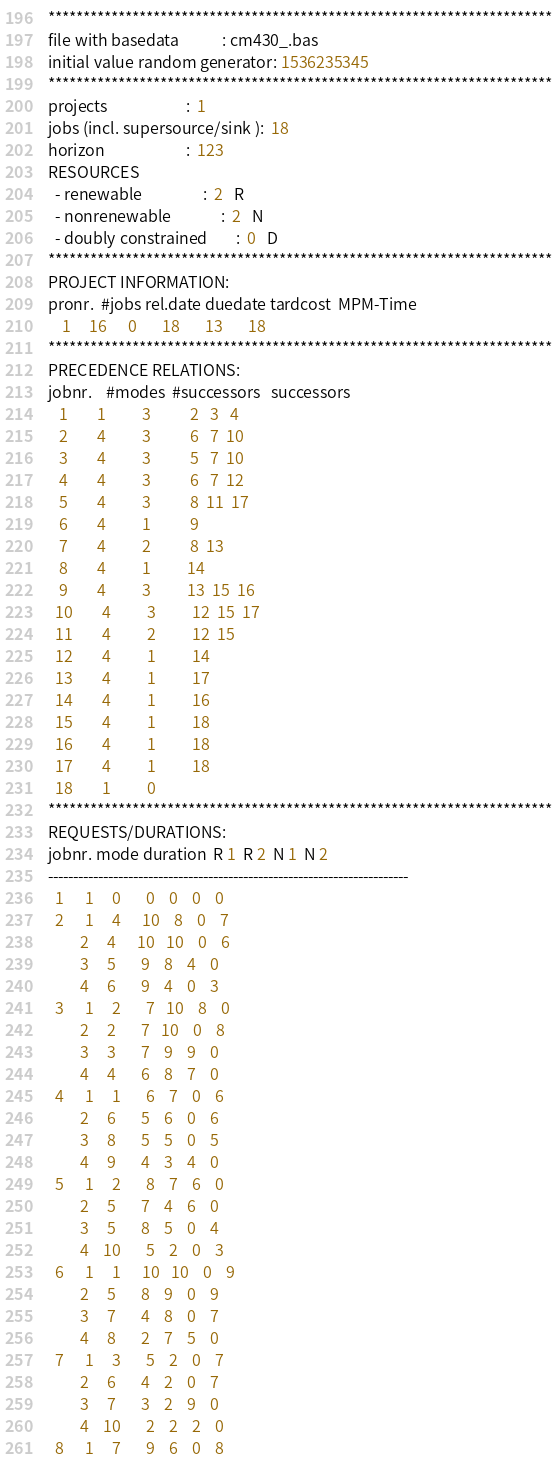Convert code to text. <code><loc_0><loc_0><loc_500><loc_500><_ObjectiveC_>************************************************************************
file with basedata            : cm430_.bas
initial value random generator: 1536235345
************************************************************************
projects                      :  1
jobs (incl. supersource/sink ):  18
horizon                       :  123
RESOURCES
  - renewable                 :  2   R
  - nonrenewable              :  2   N
  - doubly constrained        :  0   D
************************************************************************
PROJECT INFORMATION:
pronr.  #jobs rel.date duedate tardcost  MPM-Time
    1     16      0       18       13       18
************************************************************************
PRECEDENCE RELATIONS:
jobnr.    #modes  #successors   successors
   1        1          3           2   3   4
   2        4          3           6   7  10
   3        4          3           5   7  10
   4        4          3           6   7  12
   5        4          3           8  11  17
   6        4          1           9
   7        4          2           8  13
   8        4          1          14
   9        4          3          13  15  16
  10        4          3          12  15  17
  11        4          2          12  15
  12        4          1          14
  13        4          1          17
  14        4          1          16
  15        4          1          18
  16        4          1          18
  17        4          1          18
  18        1          0        
************************************************************************
REQUESTS/DURATIONS:
jobnr. mode duration  R 1  R 2  N 1  N 2
------------------------------------------------------------------------
  1      1     0       0    0    0    0
  2      1     4      10    8    0    7
         2     4      10   10    0    6
         3     5       9    8    4    0
         4     6       9    4    0    3
  3      1     2       7   10    8    0
         2     2       7   10    0    8
         3     3       7    9    9    0
         4     4       6    8    7    0
  4      1     1       6    7    0    6
         2     6       5    6    0    6
         3     8       5    5    0    5
         4     9       4    3    4    0
  5      1     2       8    7    6    0
         2     5       7    4    6    0
         3     5       8    5    0    4
         4    10       5    2    0    3
  6      1     1      10   10    0    9
         2     5       8    9    0    9
         3     7       4    8    0    7
         4     8       2    7    5    0
  7      1     3       5    2    0    7
         2     6       4    2    0    7
         3     7       3    2    9    0
         4    10       2    2    2    0
  8      1     7       9    6    0    8</code> 